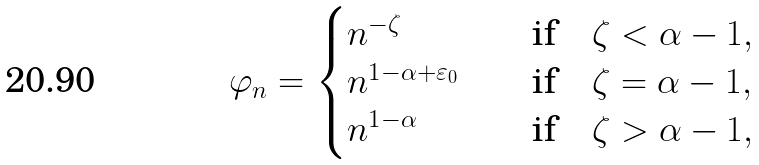Convert formula to latex. <formula><loc_0><loc_0><loc_500><loc_500>\varphi _ { n } = \begin{cases} { n ^ { - \zeta } } & \quad \text {if} \quad \zeta < \alpha - 1 , \\ { n ^ { 1 - \alpha + \varepsilon _ { 0 } } } & \quad \text {if} \quad \zeta = \alpha - 1 , \\ n ^ { 1 - \alpha } & \quad \text {if} \quad \zeta > \alpha - 1 , \end{cases}</formula> 